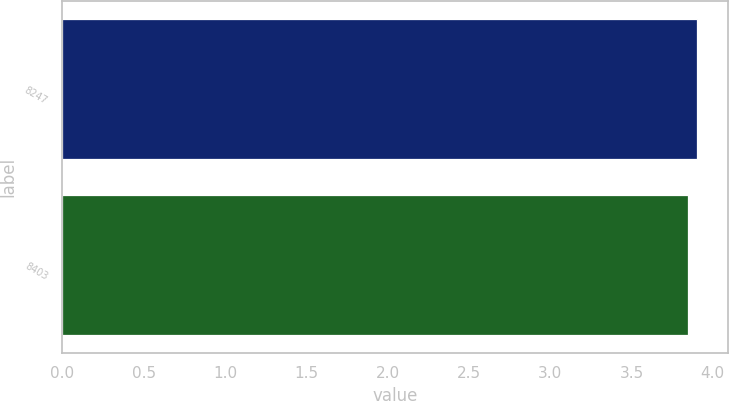Convert chart to OTSL. <chart><loc_0><loc_0><loc_500><loc_500><bar_chart><fcel>8247<fcel>8403<nl><fcel>3.9<fcel>3.85<nl></chart> 